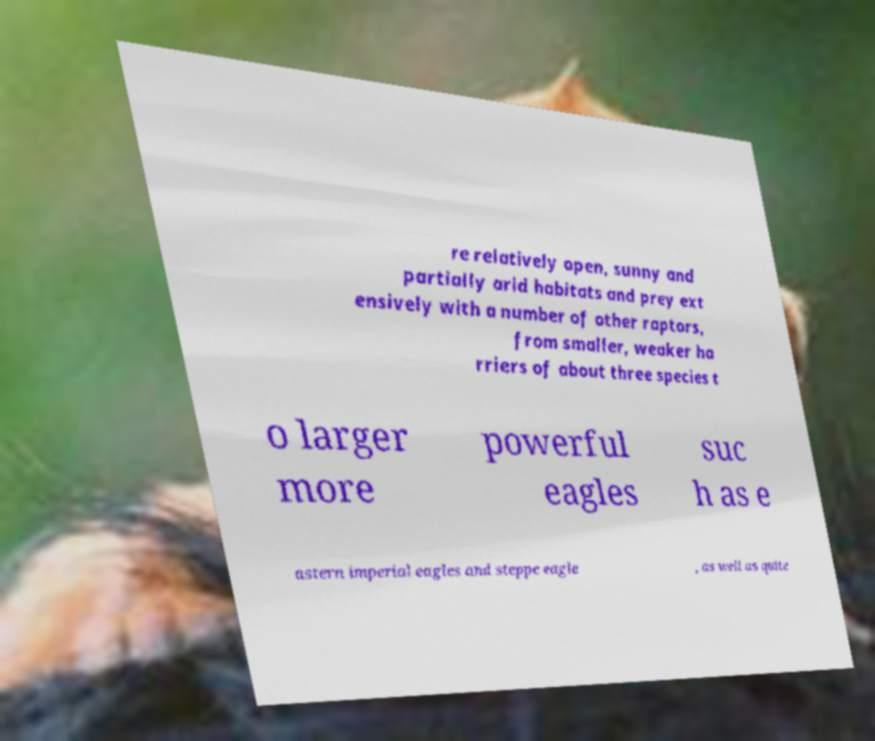Could you extract and type out the text from this image? re relatively open, sunny and partially arid habitats and prey ext ensively with a number of other raptors, from smaller, weaker ha rriers of about three species t o larger more powerful eagles suc h as e astern imperial eagles and steppe eagle , as well as quite 